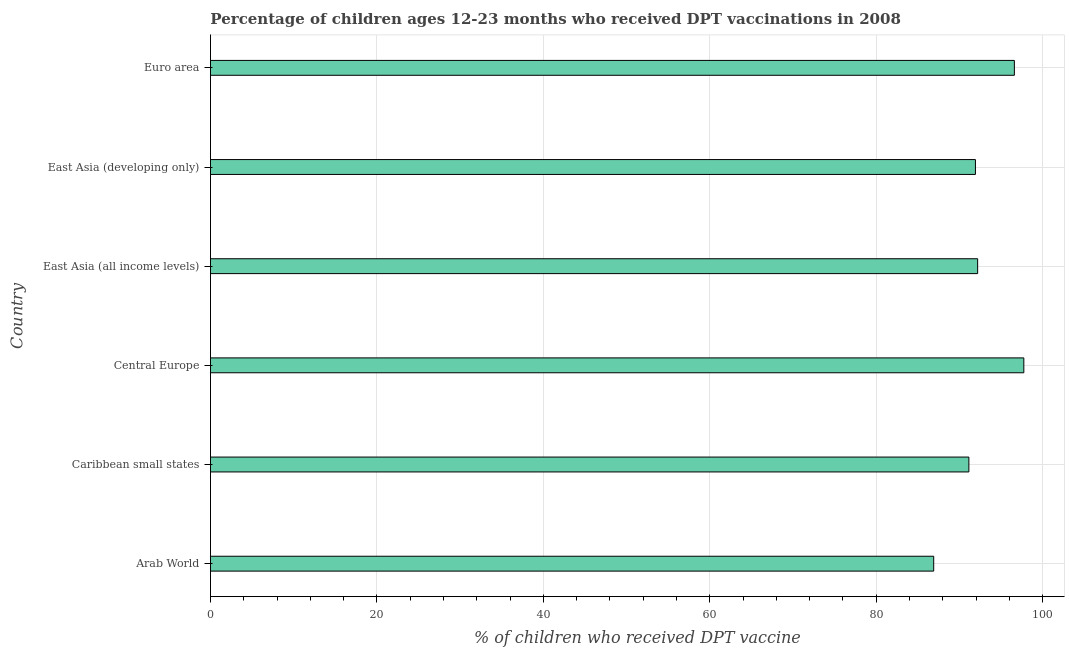Does the graph contain any zero values?
Your answer should be very brief. No. What is the title of the graph?
Provide a succinct answer. Percentage of children ages 12-23 months who received DPT vaccinations in 2008. What is the label or title of the X-axis?
Provide a succinct answer. % of children who received DPT vaccine. What is the label or title of the Y-axis?
Offer a terse response. Country. What is the percentage of children who received dpt vaccine in East Asia (developing only)?
Provide a succinct answer. 91.93. Across all countries, what is the maximum percentage of children who received dpt vaccine?
Provide a short and direct response. 97.75. Across all countries, what is the minimum percentage of children who received dpt vaccine?
Ensure brevity in your answer.  86.91. In which country was the percentage of children who received dpt vaccine maximum?
Your answer should be compact. Central Europe. In which country was the percentage of children who received dpt vaccine minimum?
Keep it short and to the point. Arab World. What is the sum of the percentage of children who received dpt vaccine?
Provide a short and direct response. 556.54. What is the difference between the percentage of children who received dpt vaccine in Central Europe and Euro area?
Offer a very short reply. 1.14. What is the average percentage of children who received dpt vaccine per country?
Keep it short and to the point. 92.76. What is the median percentage of children who received dpt vaccine?
Make the answer very short. 92.06. What is the ratio of the percentage of children who received dpt vaccine in Central Europe to that in East Asia (all income levels)?
Your answer should be very brief. 1.06. Is the difference between the percentage of children who received dpt vaccine in East Asia (all income levels) and East Asia (developing only) greater than the difference between any two countries?
Ensure brevity in your answer.  No. What is the difference between the highest and the second highest percentage of children who received dpt vaccine?
Give a very brief answer. 1.14. Is the sum of the percentage of children who received dpt vaccine in Arab World and Caribbean small states greater than the maximum percentage of children who received dpt vaccine across all countries?
Your response must be concise. Yes. What is the difference between the highest and the lowest percentage of children who received dpt vaccine?
Provide a short and direct response. 10.83. In how many countries, is the percentage of children who received dpt vaccine greater than the average percentage of children who received dpt vaccine taken over all countries?
Your response must be concise. 2. How many bars are there?
Offer a terse response. 6. Are all the bars in the graph horizontal?
Provide a short and direct response. Yes. How many countries are there in the graph?
Your answer should be compact. 6. Are the values on the major ticks of X-axis written in scientific E-notation?
Provide a succinct answer. No. What is the % of children who received DPT vaccine of Arab World?
Your response must be concise. 86.91. What is the % of children who received DPT vaccine of Caribbean small states?
Your answer should be very brief. 91.14. What is the % of children who received DPT vaccine of Central Europe?
Offer a terse response. 97.75. What is the % of children who received DPT vaccine in East Asia (all income levels)?
Ensure brevity in your answer.  92.19. What is the % of children who received DPT vaccine of East Asia (developing only)?
Make the answer very short. 91.93. What is the % of children who received DPT vaccine of Euro area?
Make the answer very short. 96.61. What is the difference between the % of children who received DPT vaccine in Arab World and Caribbean small states?
Ensure brevity in your answer.  -4.23. What is the difference between the % of children who received DPT vaccine in Arab World and Central Europe?
Your answer should be very brief. -10.83. What is the difference between the % of children who received DPT vaccine in Arab World and East Asia (all income levels)?
Give a very brief answer. -5.28. What is the difference between the % of children who received DPT vaccine in Arab World and East Asia (developing only)?
Ensure brevity in your answer.  -5.02. What is the difference between the % of children who received DPT vaccine in Arab World and Euro area?
Your response must be concise. -9.7. What is the difference between the % of children who received DPT vaccine in Caribbean small states and Central Europe?
Offer a very short reply. -6.6. What is the difference between the % of children who received DPT vaccine in Caribbean small states and East Asia (all income levels)?
Your answer should be very brief. -1.05. What is the difference between the % of children who received DPT vaccine in Caribbean small states and East Asia (developing only)?
Keep it short and to the point. -0.79. What is the difference between the % of children who received DPT vaccine in Caribbean small states and Euro area?
Provide a short and direct response. -5.47. What is the difference between the % of children who received DPT vaccine in Central Europe and East Asia (all income levels)?
Offer a very short reply. 5.55. What is the difference between the % of children who received DPT vaccine in Central Europe and East Asia (developing only)?
Offer a terse response. 5.81. What is the difference between the % of children who received DPT vaccine in Central Europe and Euro area?
Make the answer very short. 1.14. What is the difference between the % of children who received DPT vaccine in East Asia (all income levels) and East Asia (developing only)?
Your response must be concise. 0.26. What is the difference between the % of children who received DPT vaccine in East Asia (all income levels) and Euro area?
Provide a short and direct response. -4.42. What is the difference between the % of children who received DPT vaccine in East Asia (developing only) and Euro area?
Provide a succinct answer. -4.68. What is the ratio of the % of children who received DPT vaccine in Arab World to that in Caribbean small states?
Your response must be concise. 0.95. What is the ratio of the % of children who received DPT vaccine in Arab World to that in Central Europe?
Provide a succinct answer. 0.89. What is the ratio of the % of children who received DPT vaccine in Arab World to that in East Asia (all income levels)?
Give a very brief answer. 0.94. What is the ratio of the % of children who received DPT vaccine in Arab World to that in East Asia (developing only)?
Ensure brevity in your answer.  0.94. What is the ratio of the % of children who received DPT vaccine in Caribbean small states to that in Central Europe?
Your response must be concise. 0.93. What is the ratio of the % of children who received DPT vaccine in Caribbean small states to that in Euro area?
Ensure brevity in your answer.  0.94. What is the ratio of the % of children who received DPT vaccine in Central Europe to that in East Asia (all income levels)?
Your response must be concise. 1.06. What is the ratio of the % of children who received DPT vaccine in Central Europe to that in East Asia (developing only)?
Provide a succinct answer. 1.06. What is the ratio of the % of children who received DPT vaccine in Central Europe to that in Euro area?
Your answer should be compact. 1.01. What is the ratio of the % of children who received DPT vaccine in East Asia (all income levels) to that in Euro area?
Make the answer very short. 0.95. What is the ratio of the % of children who received DPT vaccine in East Asia (developing only) to that in Euro area?
Provide a succinct answer. 0.95. 